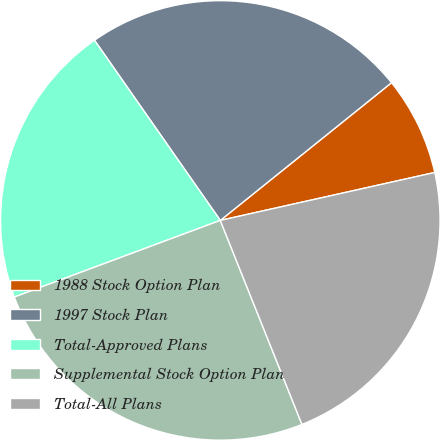Convert chart. <chart><loc_0><loc_0><loc_500><loc_500><pie_chart><fcel>1988 Stock Option Plan<fcel>1997 Stock Plan<fcel>Total-Approved Plans<fcel>Supplemental Stock Option Plan<fcel>Total-All Plans<nl><fcel>7.28%<fcel>23.92%<fcel>20.97%<fcel>25.39%<fcel>22.44%<nl></chart> 